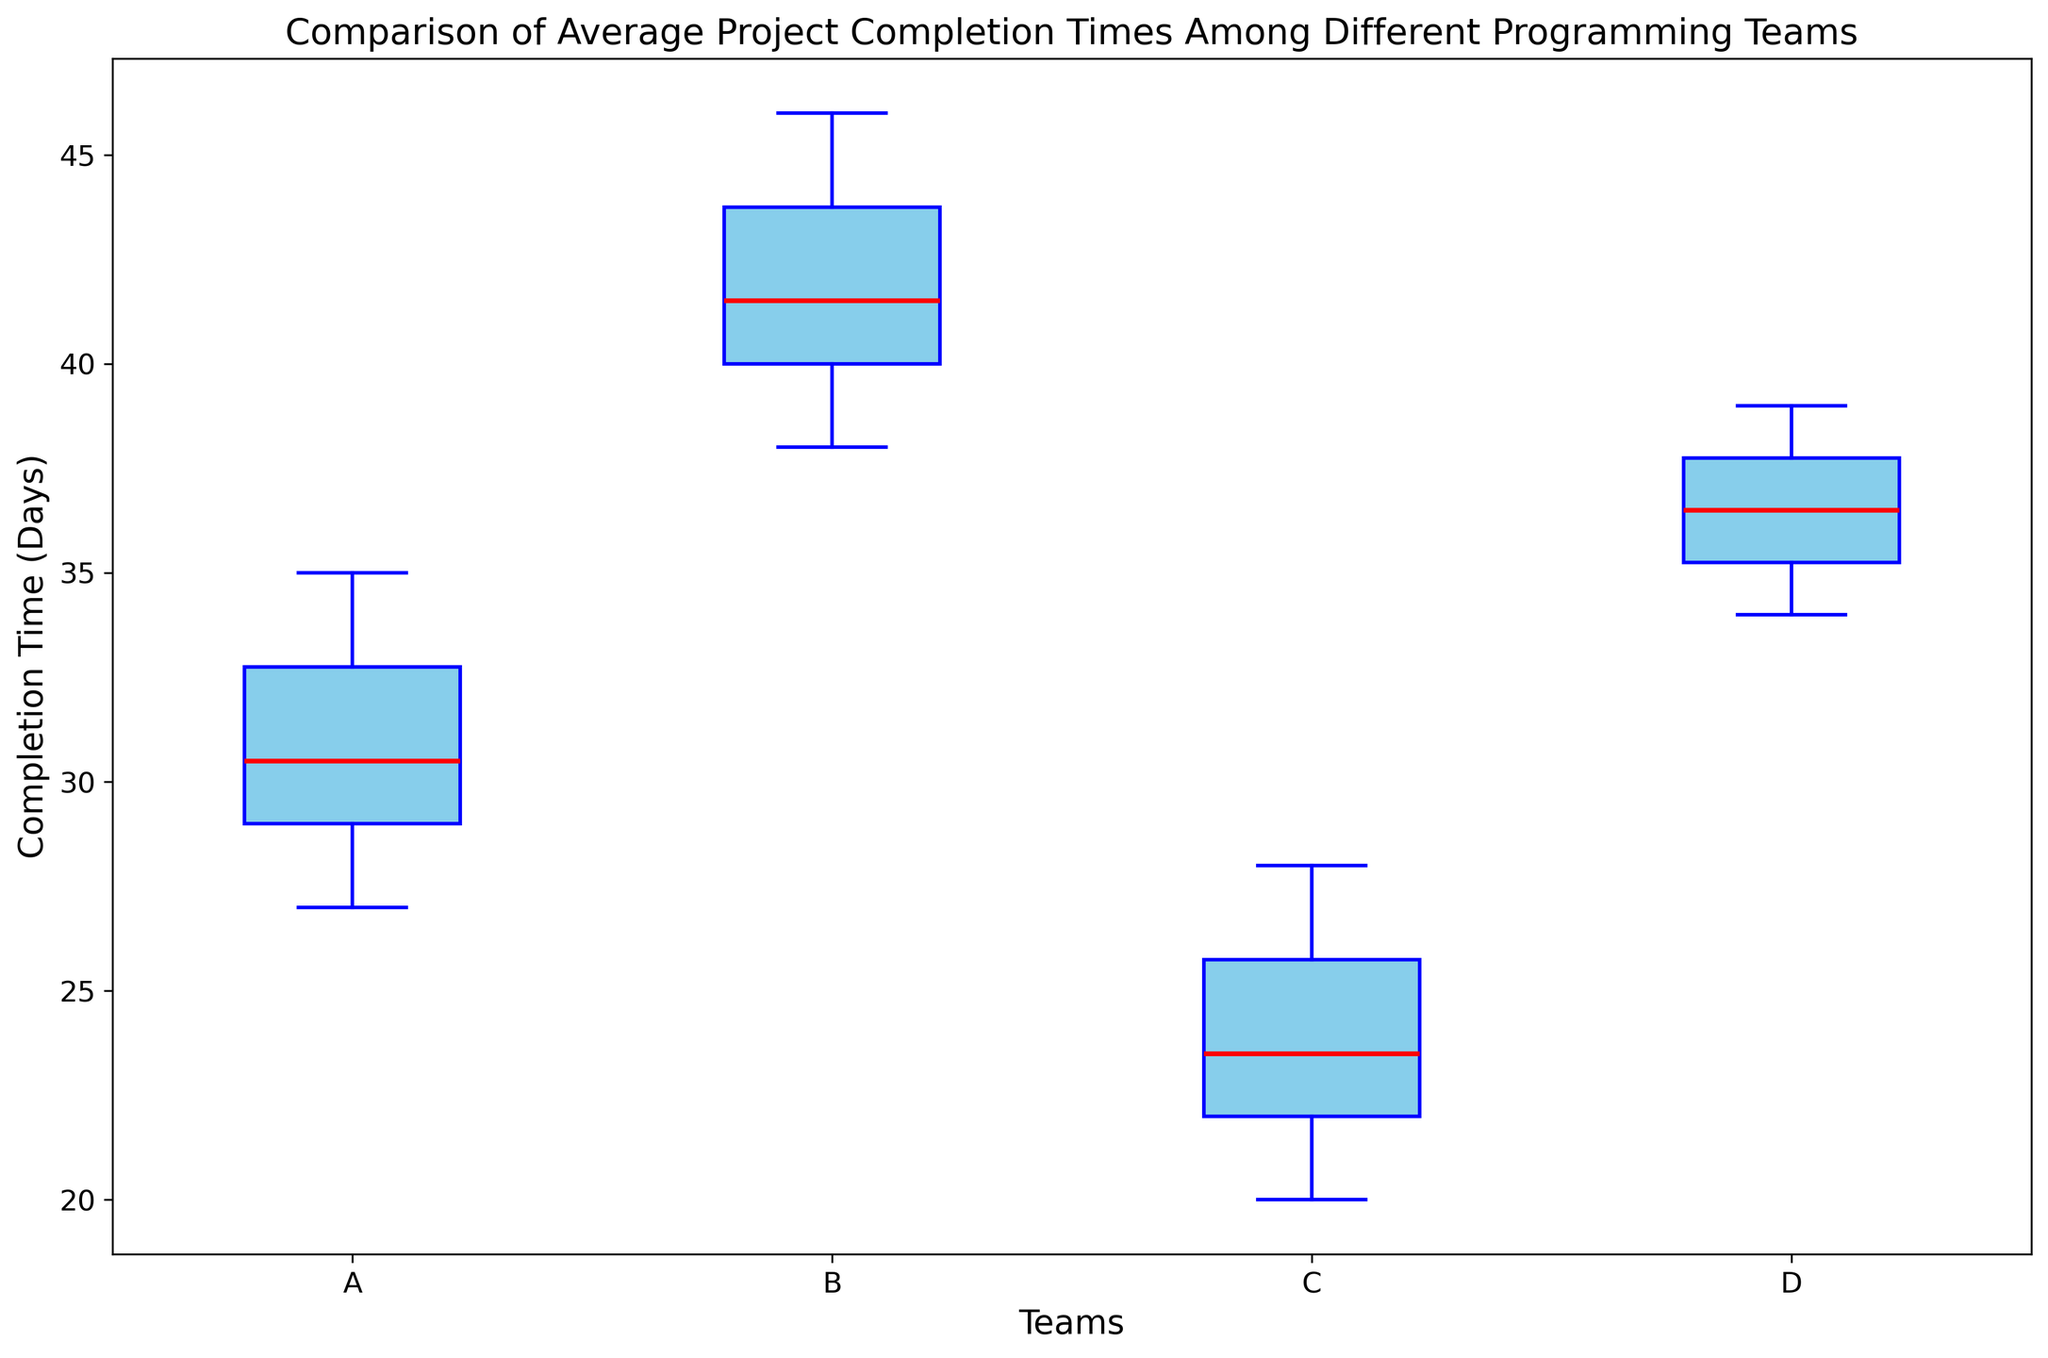Which team has the highest median project completion time? Looking at the box plot, the red line in each box represents the median. The team with the highest median is Team B.
Answer: Team B Which team has the lowest median project completion time? The team with the lowest median completion time is represented by the red line, which is lowest for Team C.
Answer: Team C What is the range of completion times for Team D? The range is calculated by subtracting the minimum value (the bottom whisker) from the maximum value (the top whisker) for Team D. From the plot, the range for Team D is 39 - 34 = 5 days.
Answer: 5 days Which team has the widest interquartile range (IQR)? The IQR is the width of the box, which represents the range between the first quartile (Q1) and the third quartile (Q3). Team B has the widest box, indicating the largest IQR.
Answer: Team B Which teams have outliers in their completion times? Outliers are represented by the circles outside the whiskers. According to the box plot, only Team C has visible outliers.
Answer: Team C Compare the median completion times between Team A and Team D. The median is represented by the red line within each box. Comparing the median lines, Team D's median is higher than Team A's median.
Answer: Team D's median is higher than Team A's Which team has the smallest range of completion times? The range is the difference between the maximum and minimum values, represented by the whiskers. Team C has the smallest range of completion times.
Answer: Team C What is the approximate difference in median completion time between Team A and Team B? To find the difference, subtract the median of Team A (around 30) from the median of Team B (around 42). So, 42 - 30 = 12 days.
Answer: 12 days How does the median completion time of Team C compare to the first quartile completion time of Team D? In the box plot, the median of Team C (around 23) is compared to the bottom of the box of Team D (around 35). The median of Team C is less than the first quartile of Team D.
Answer: The median of Team C is lower than the first quartile of Team D 